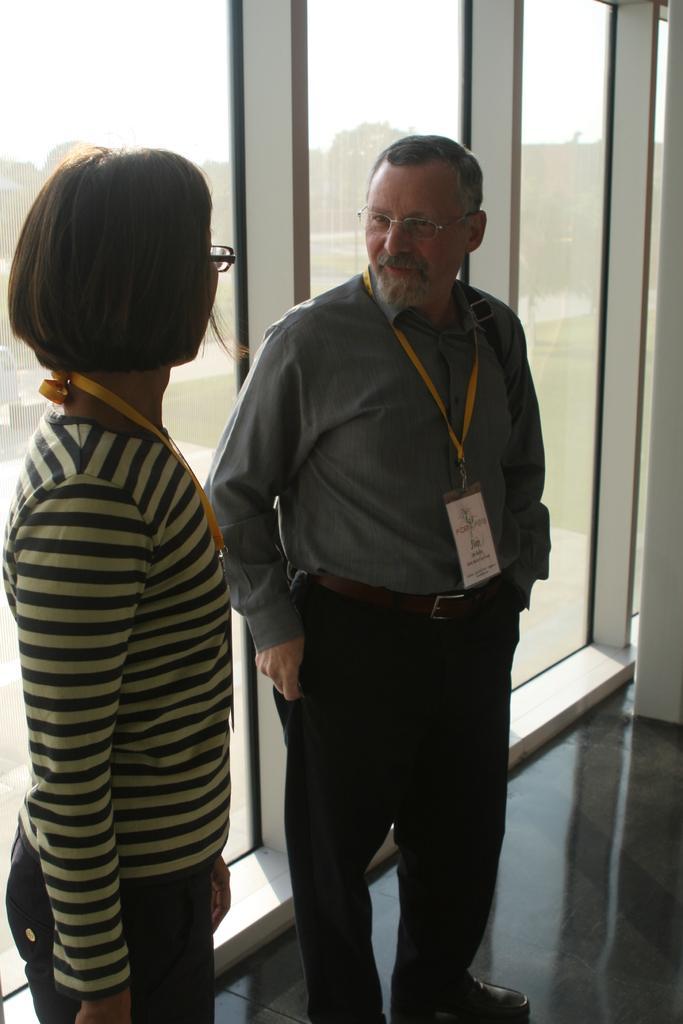How would you summarize this image in a sentence or two? In this picture we can see two people on the floor and in the background we can see a glass door, through the glass door we can see trees and the sky. 